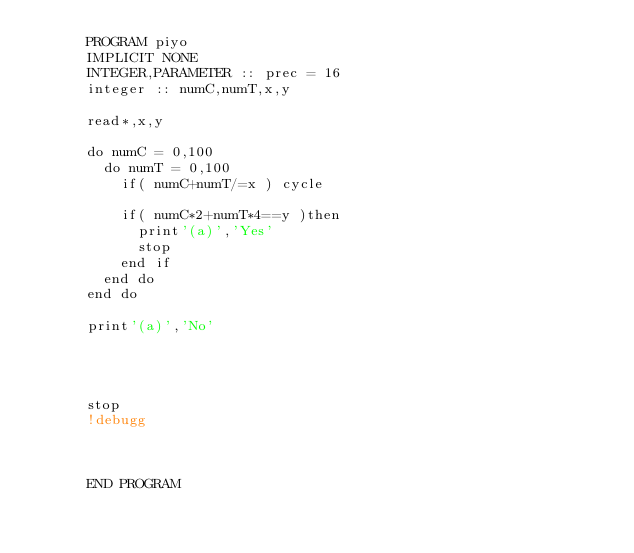Convert code to text. <code><loc_0><loc_0><loc_500><loc_500><_FORTRAN_>      PROGRAM piyo
      IMPLICIT NONE
      INTEGER,PARAMETER :: prec = 16
      integer :: numC,numT,x,y
      
      read*,x,y
      
      do numC = 0,100
        do numT = 0,100
          if( numC+numT/=x ) cycle
          
          if( numC*2+numT*4==y )then
            print'(a)','Yes'
            stop
          end if
        end do
      end do
      
      print'(a)','No'
      
      
      
      
      stop
      !debugg
      
      
      
      END PROGRAM</code> 